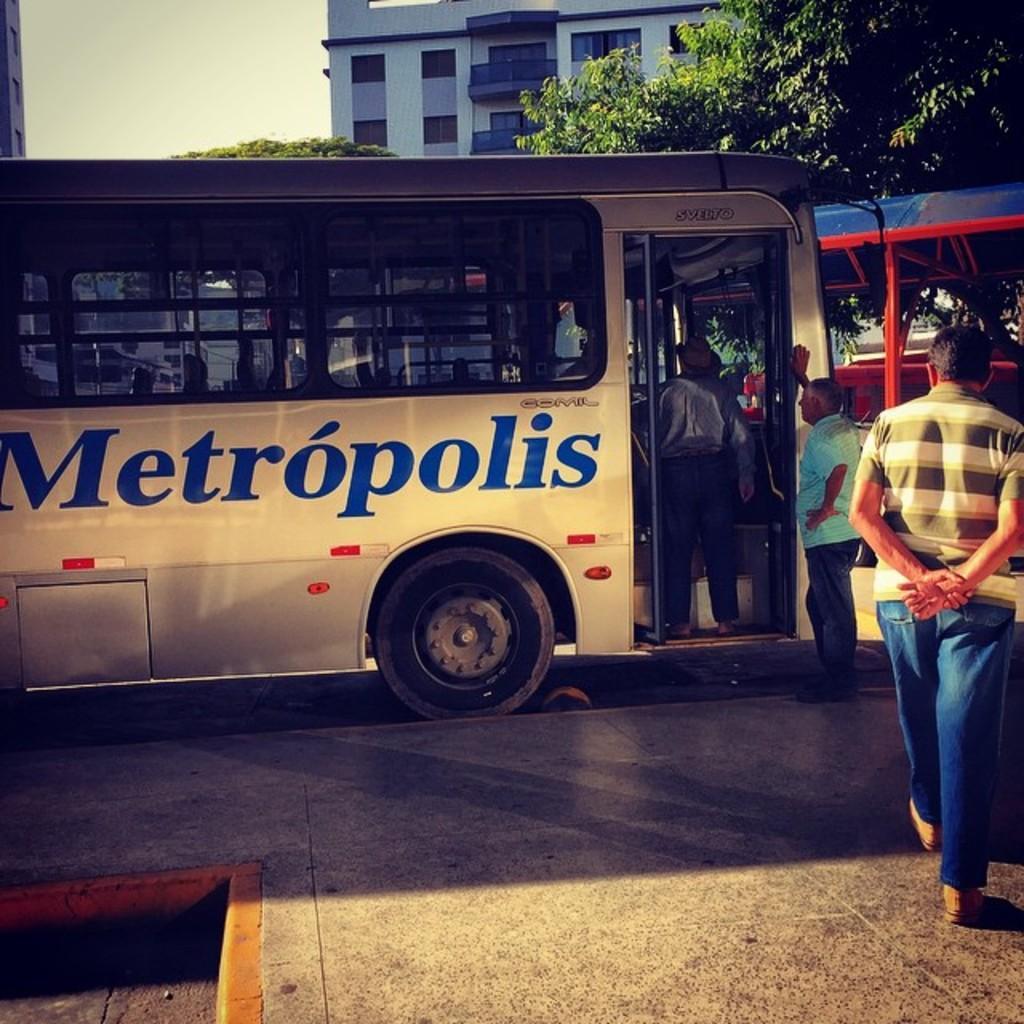How would you summarize this image in a sentence or two? As we can see in the image there is bus, few people, buildings and trees. At the top there is sky. 